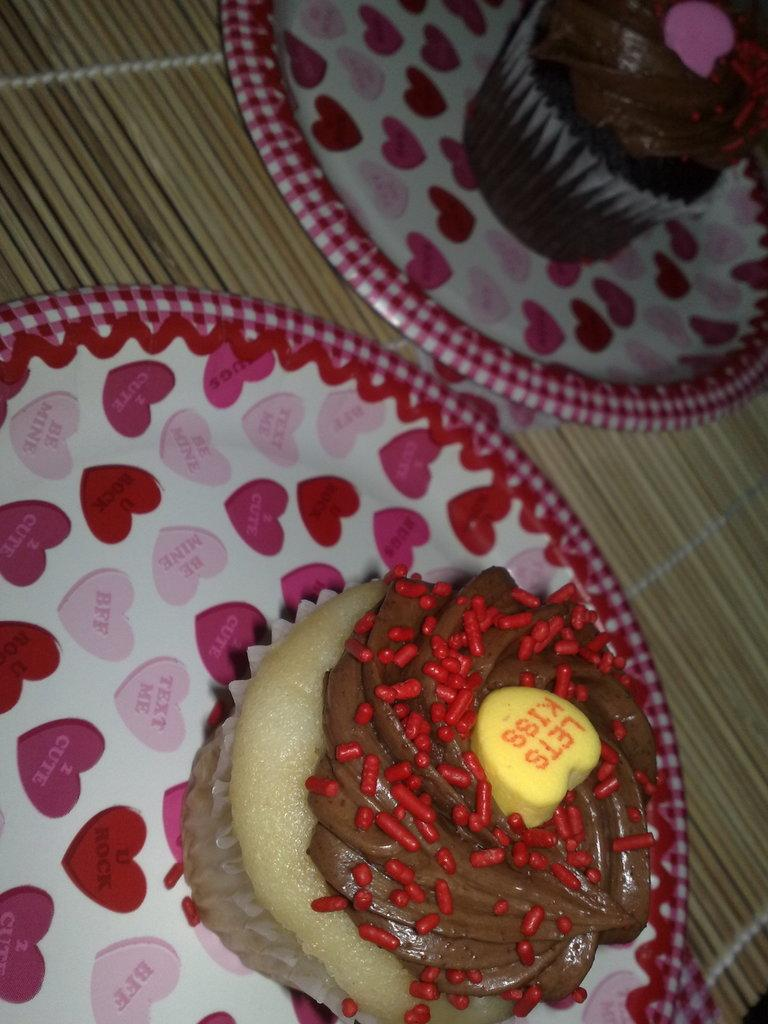What piece of furniture is present in the image? There is a table in the image. How many plates are on the table? There are two plates on the table. What type of food is on the plates? There are two cupcakes on the plates. What type of cushion is placed on the arch in the image? There is no cushion or arch present in the image. 